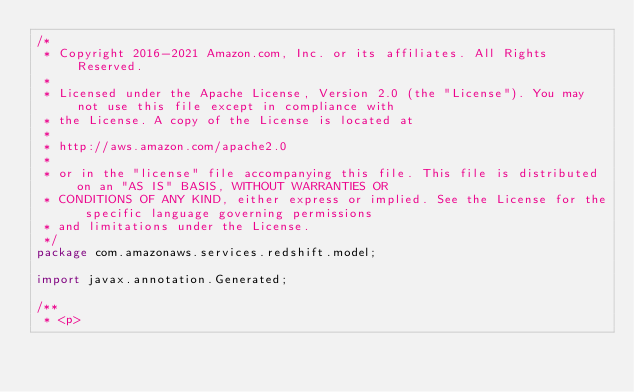Convert code to text. <code><loc_0><loc_0><loc_500><loc_500><_Java_>/*
 * Copyright 2016-2021 Amazon.com, Inc. or its affiliates. All Rights Reserved.
 * 
 * Licensed under the Apache License, Version 2.0 (the "License"). You may not use this file except in compliance with
 * the License. A copy of the License is located at
 * 
 * http://aws.amazon.com/apache2.0
 * 
 * or in the "license" file accompanying this file. This file is distributed on an "AS IS" BASIS, WITHOUT WARRANTIES OR
 * CONDITIONS OF ANY KIND, either express or implied. See the License for the specific language governing permissions
 * and limitations under the License.
 */
package com.amazonaws.services.redshift.model;

import javax.annotation.Generated;

/**
 * <p></code> 